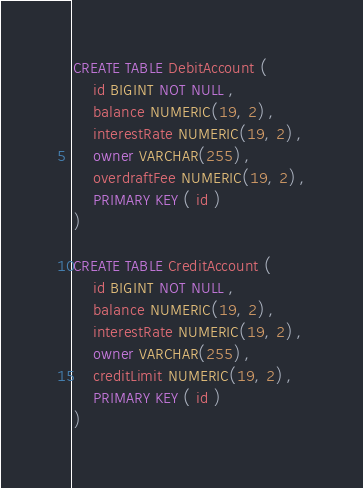<code> <loc_0><loc_0><loc_500><loc_500><_SQL_>CREATE TABLE DebitAccount (
    id BIGINT NOT NULL ,
    balance NUMERIC(19, 2) ,
    interestRate NUMERIC(19, 2) ,
    owner VARCHAR(255) ,
    overdraftFee NUMERIC(19, 2) ,
    PRIMARY KEY ( id )
)

CREATE TABLE CreditAccount (
    id BIGINT NOT NULL ,
    balance NUMERIC(19, 2) ,
    interestRate NUMERIC(19, 2) ,
    owner VARCHAR(255) ,
    creditLimit NUMERIC(19, 2) ,
    PRIMARY KEY ( id )
)</code> 